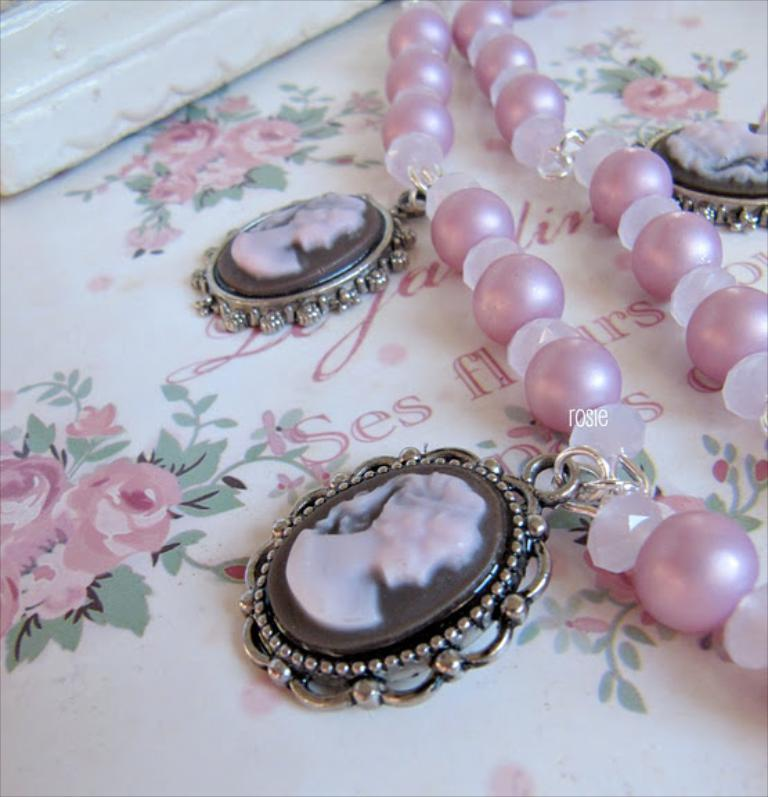What is the main subject of the picture? The main subject of the picture is an ornament. What is attached to the ornament? There are lockets attached to the ornament. What can be seen in the background of the picture? There is a picture of flowers and text visible in the background. How many rats are visible in the picture? There are no rats present in the image. What type of heat source is used to create the picture? The image is a still photograph, so there is no heat source involved in creating the picture. 